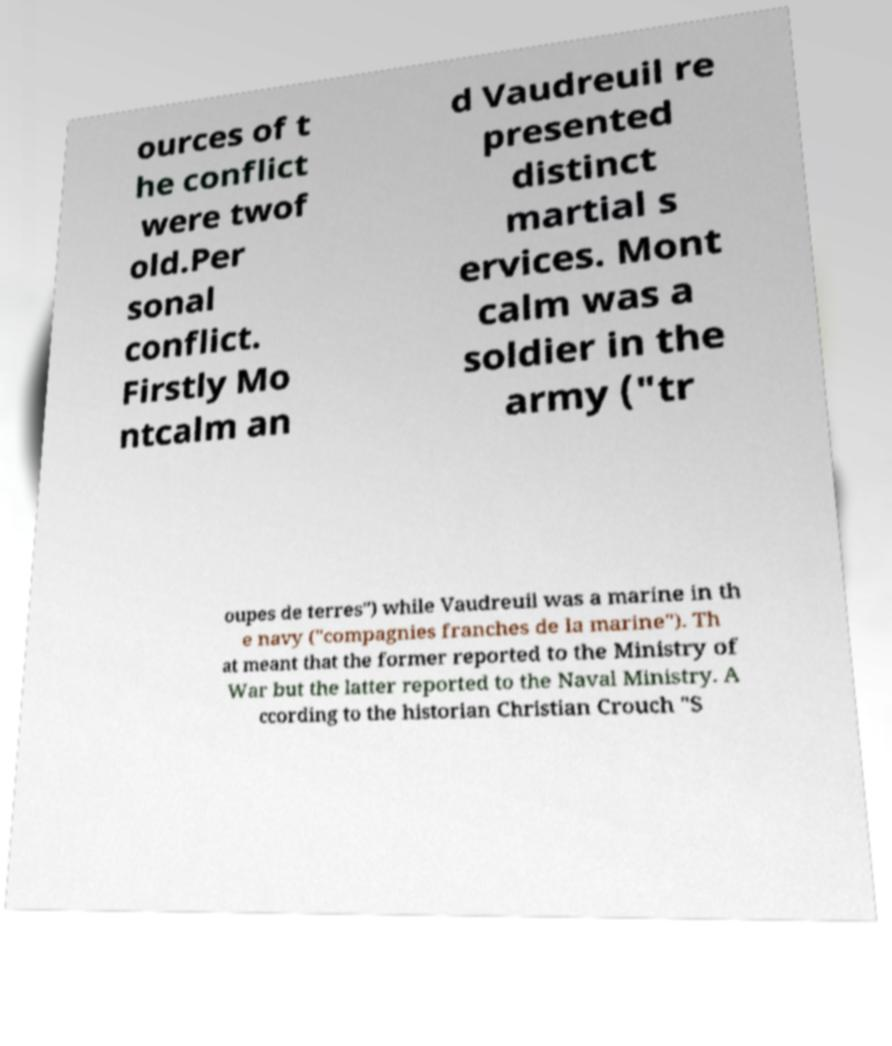Can you read and provide the text displayed in the image?This photo seems to have some interesting text. Can you extract and type it out for me? ources of t he conflict were twof old.Per sonal conflict. Firstly Mo ntcalm an d Vaudreuil re presented distinct martial s ervices. Mont calm was a soldier in the army ("tr oupes de terres") while Vaudreuil was a marine in th e navy ("compagnies franches de la marine"). Th at meant that the former reported to the Ministry of War but the latter reported to the Naval Ministry. A ccording to the historian Christian Crouch "S 